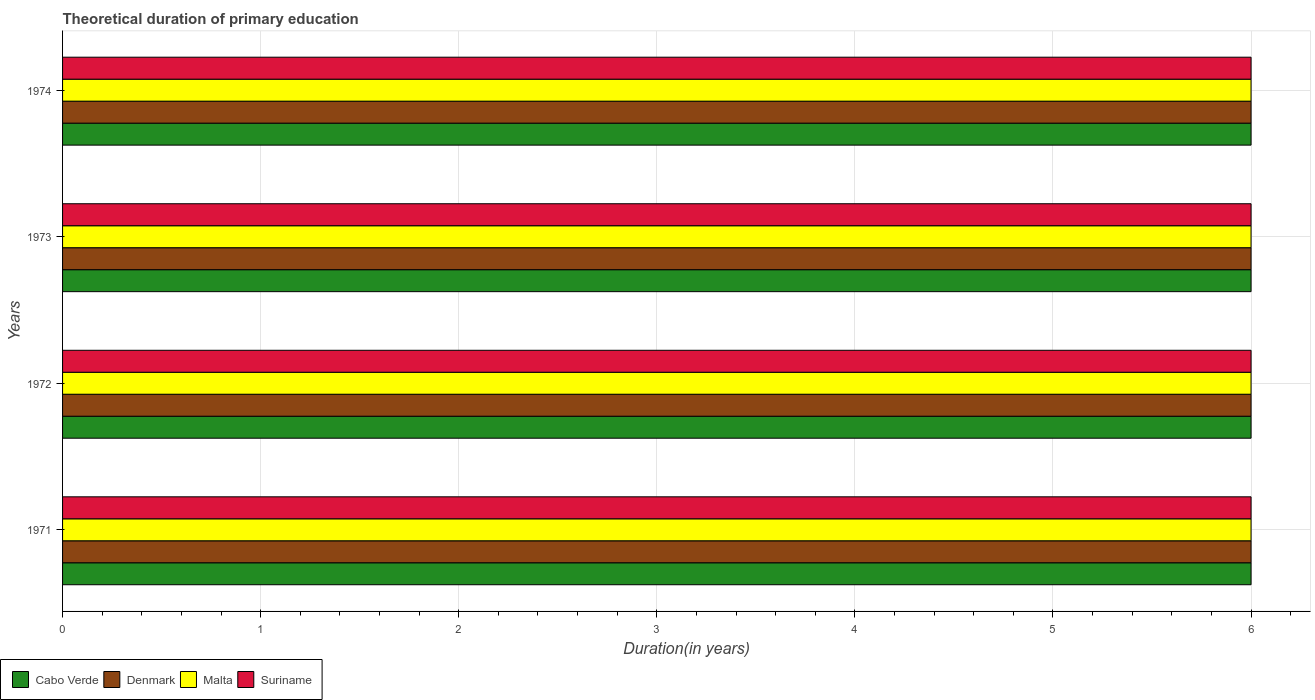How many different coloured bars are there?
Offer a very short reply. 4. How many groups of bars are there?
Give a very brief answer. 4. Are the number of bars per tick equal to the number of legend labels?
Your answer should be very brief. Yes. Are the number of bars on each tick of the Y-axis equal?
Provide a succinct answer. Yes. How many bars are there on the 4th tick from the top?
Make the answer very short. 4. What is the label of the 1st group of bars from the top?
Your answer should be compact. 1974. Across all years, what is the minimum total theoretical duration of primary education in Cabo Verde?
Your answer should be very brief. 6. In which year was the total theoretical duration of primary education in Cabo Verde maximum?
Your response must be concise. 1971. In which year was the total theoretical duration of primary education in Cabo Verde minimum?
Your response must be concise. 1971. What is the total total theoretical duration of primary education in Cabo Verde in the graph?
Give a very brief answer. 24. What is the difference between the total theoretical duration of primary education in Cabo Verde in 1973 and the total theoretical duration of primary education in Malta in 1972?
Offer a very short reply. 0. In the year 1972, what is the difference between the total theoretical duration of primary education in Denmark and total theoretical duration of primary education in Suriname?
Ensure brevity in your answer.  0. In how many years, is the total theoretical duration of primary education in Cabo Verde greater than 0.4 years?
Provide a succinct answer. 4. What is the ratio of the total theoretical duration of primary education in Cabo Verde in 1971 to that in 1974?
Offer a terse response. 1. Is the total theoretical duration of primary education in Cabo Verde in 1972 less than that in 1973?
Your answer should be very brief. No. What is the difference between the highest and the lowest total theoretical duration of primary education in Cabo Verde?
Your response must be concise. 0. Is the sum of the total theoretical duration of primary education in Denmark in 1972 and 1973 greater than the maximum total theoretical duration of primary education in Cabo Verde across all years?
Your response must be concise. Yes. What does the 2nd bar from the top in 1974 represents?
Your response must be concise. Malta. What does the 3rd bar from the bottom in 1972 represents?
Offer a very short reply. Malta. Is it the case that in every year, the sum of the total theoretical duration of primary education in Cabo Verde and total theoretical duration of primary education in Denmark is greater than the total theoretical duration of primary education in Malta?
Make the answer very short. Yes. Does the graph contain any zero values?
Your response must be concise. No. Does the graph contain grids?
Your response must be concise. Yes. Where does the legend appear in the graph?
Provide a succinct answer. Bottom left. How many legend labels are there?
Offer a very short reply. 4. What is the title of the graph?
Give a very brief answer. Theoretical duration of primary education. Does "Mozambique" appear as one of the legend labels in the graph?
Provide a short and direct response. No. What is the label or title of the X-axis?
Offer a terse response. Duration(in years). What is the Duration(in years) in Cabo Verde in 1971?
Give a very brief answer. 6. What is the Duration(in years) in Cabo Verde in 1972?
Provide a succinct answer. 6. What is the Duration(in years) of Denmark in 1972?
Ensure brevity in your answer.  6. What is the Duration(in years) in Malta in 1972?
Provide a succinct answer. 6. What is the Duration(in years) of Suriname in 1972?
Keep it short and to the point. 6. What is the Duration(in years) of Cabo Verde in 1973?
Give a very brief answer. 6. What is the Duration(in years) in Denmark in 1973?
Your answer should be compact. 6. What is the Duration(in years) in Cabo Verde in 1974?
Make the answer very short. 6. What is the Duration(in years) of Suriname in 1974?
Provide a succinct answer. 6. Across all years, what is the maximum Duration(in years) in Malta?
Give a very brief answer. 6. Across all years, what is the minimum Duration(in years) in Cabo Verde?
Give a very brief answer. 6. Across all years, what is the minimum Duration(in years) of Malta?
Offer a terse response. 6. What is the total Duration(in years) of Denmark in the graph?
Keep it short and to the point. 24. What is the total Duration(in years) of Malta in the graph?
Keep it short and to the point. 24. What is the total Duration(in years) in Suriname in the graph?
Offer a terse response. 24. What is the difference between the Duration(in years) in Cabo Verde in 1971 and that in 1972?
Offer a terse response. 0. What is the difference between the Duration(in years) in Suriname in 1971 and that in 1972?
Provide a short and direct response. 0. What is the difference between the Duration(in years) of Cabo Verde in 1971 and that in 1973?
Your response must be concise. 0. What is the difference between the Duration(in years) of Malta in 1971 and that in 1973?
Offer a very short reply. 0. What is the difference between the Duration(in years) in Suriname in 1971 and that in 1973?
Give a very brief answer. 0. What is the difference between the Duration(in years) of Suriname in 1971 and that in 1974?
Offer a very short reply. 0. What is the difference between the Duration(in years) of Malta in 1972 and that in 1973?
Your answer should be compact. 0. What is the difference between the Duration(in years) of Cabo Verde in 1972 and that in 1974?
Offer a terse response. 0. What is the difference between the Duration(in years) of Denmark in 1972 and that in 1974?
Your answer should be compact. 0. What is the difference between the Duration(in years) in Malta in 1972 and that in 1974?
Your answer should be very brief. 0. What is the difference between the Duration(in years) in Malta in 1973 and that in 1974?
Your response must be concise. 0. What is the difference between the Duration(in years) of Suriname in 1973 and that in 1974?
Keep it short and to the point. 0. What is the difference between the Duration(in years) in Cabo Verde in 1971 and the Duration(in years) in Malta in 1972?
Provide a short and direct response. 0. What is the difference between the Duration(in years) in Cabo Verde in 1971 and the Duration(in years) in Suriname in 1972?
Offer a very short reply. 0. What is the difference between the Duration(in years) in Cabo Verde in 1971 and the Duration(in years) in Denmark in 1973?
Provide a succinct answer. 0. What is the difference between the Duration(in years) in Cabo Verde in 1971 and the Duration(in years) in Malta in 1973?
Provide a succinct answer. 0. What is the difference between the Duration(in years) in Denmark in 1971 and the Duration(in years) in Malta in 1973?
Your answer should be compact. 0. What is the difference between the Duration(in years) in Cabo Verde in 1971 and the Duration(in years) in Denmark in 1974?
Keep it short and to the point. 0. What is the difference between the Duration(in years) in Cabo Verde in 1971 and the Duration(in years) in Malta in 1974?
Provide a succinct answer. 0. What is the difference between the Duration(in years) of Cabo Verde in 1971 and the Duration(in years) of Suriname in 1974?
Offer a very short reply. 0. What is the difference between the Duration(in years) in Denmark in 1971 and the Duration(in years) in Malta in 1974?
Offer a very short reply. 0. What is the difference between the Duration(in years) in Denmark in 1971 and the Duration(in years) in Suriname in 1974?
Keep it short and to the point. 0. What is the difference between the Duration(in years) of Malta in 1971 and the Duration(in years) of Suriname in 1974?
Offer a terse response. 0. What is the difference between the Duration(in years) of Denmark in 1972 and the Duration(in years) of Malta in 1973?
Ensure brevity in your answer.  0. What is the difference between the Duration(in years) in Cabo Verde in 1972 and the Duration(in years) in Denmark in 1974?
Your response must be concise. 0. What is the difference between the Duration(in years) in Cabo Verde in 1972 and the Duration(in years) in Suriname in 1974?
Provide a succinct answer. 0. What is the difference between the Duration(in years) of Denmark in 1972 and the Duration(in years) of Malta in 1974?
Your answer should be compact. 0. What is the difference between the Duration(in years) of Denmark in 1972 and the Duration(in years) of Suriname in 1974?
Provide a succinct answer. 0. What is the difference between the Duration(in years) of Malta in 1972 and the Duration(in years) of Suriname in 1974?
Provide a short and direct response. 0. What is the difference between the Duration(in years) of Malta in 1973 and the Duration(in years) of Suriname in 1974?
Provide a succinct answer. 0. What is the average Duration(in years) of Cabo Verde per year?
Give a very brief answer. 6. What is the average Duration(in years) of Denmark per year?
Ensure brevity in your answer.  6. What is the average Duration(in years) in Suriname per year?
Give a very brief answer. 6. In the year 1971, what is the difference between the Duration(in years) in Cabo Verde and Duration(in years) in Malta?
Keep it short and to the point. 0. In the year 1971, what is the difference between the Duration(in years) of Denmark and Duration(in years) of Malta?
Your answer should be compact. 0. In the year 1971, what is the difference between the Duration(in years) of Denmark and Duration(in years) of Suriname?
Offer a terse response. 0. In the year 1971, what is the difference between the Duration(in years) of Malta and Duration(in years) of Suriname?
Make the answer very short. 0. In the year 1972, what is the difference between the Duration(in years) of Cabo Verde and Duration(in years) of Suriname?
Ensure brevity in your answer.  0. In the year 1972, what is the difference between the Duration(in years) of Denmark and Duration(in years) of Suriname?
Keep it short and to the point. 0. In the year 1973, what is the difference between the Duration(in years) of Cabo Verde and Duration(in years) of Malta?
Give a very brief answer. 0. In the year 1973, what is the difference between the Duration(in years) in Cabo Verde and Duration(in years) in Suriname?
Your answer should be very brief. 0. In the year 1973, what is the difference between the Duration(in years) in Denmark and Duration(in years) in Malta?
Your answer should be very brief. 0. In the year 1973, what is the difference between the Duration(in years) in Denmark and Duration(in years) in Suriname?
Offer a very short reply. 0. In the year 1974, what is the difference between the Duration(in years) of Cabo Verde and Duration(in years) of Suriname?
Give a very brief answer. 0. In the year 1974, what is the difference between the Duration(in years) of Denmark and Duration(in years) of Malta?
Your answer should be very brief. 0. In the year 1974, what is the difference between the Duration(in years) in Malta and Duration(in years) in Suriname?
Offer a very short reply. 0. What is the ratio of the Duration(in years) of Cabo Verde in 1971 to that in 1972?
Your response must be concise. 1. What is the ratio of the Duration(in years) of Cabo Verde in 1971 to that in 1973?
Your response must be concise. 1. What is the ratio of the Duration(in years) of Suriname in 1971 to that in 1973?
Make the answer very short. 1. What is the ratio of the Duration(in years) of Cabo Verde in 1971 to that in 1974?
Your answer should be very brief. 1. What is the ratio of the Duration(in years) of Malta in 1971 to that in 1974?
Keep it short and to the point. 1. What is the ratio of the Duration(in years) in Suriname in 1971 to that in 1974?
Make the answer very short. 1. What is the ratio of the Duration(in years) in Cabo Verde in 1972 to that in 1974?
Give a very brief answer. 1. What is the ratio of the Duration(in years) in Denmark in 1972 to that in 1974?
Ensure brevity in your answer.  1. What is the ratio of the Duration(in years) in Malta in 1972 to that in 1974?
Provide a succinct answer. 1. What is the ratio of the Duration(in years) in Suriname in 1972 to that in 1974?
Provide a succinct answer. 1. What is the ratio of the Duration(in years) of Denmark in 1973 to that in 1974?
Ensure brevity in your answer.  1. What is the ratio of the Duration(in years) in Suriname in 1973 to that in 1974?
Your answer should be very brief. 1. What is the difference between the highest and the second highest Duration(in years) in Cabo Verde?
Make the answer very short. 0. What is the difference between the highest and the second highest Duration(in years) in Malta?
Provide a succinct answer. 0. 